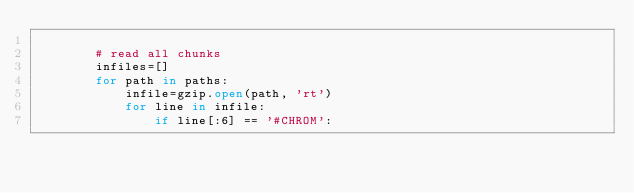Convert code to text. <code><loc_0><loc_0><loc_500><loc_500><_Python_>        
        # read all chunks
        infiles=[]
        for path in paths:
            infile=gzip.open(path, 'rt')
            for line in infile:
                if line[:6] == '#CHROM':</code> 